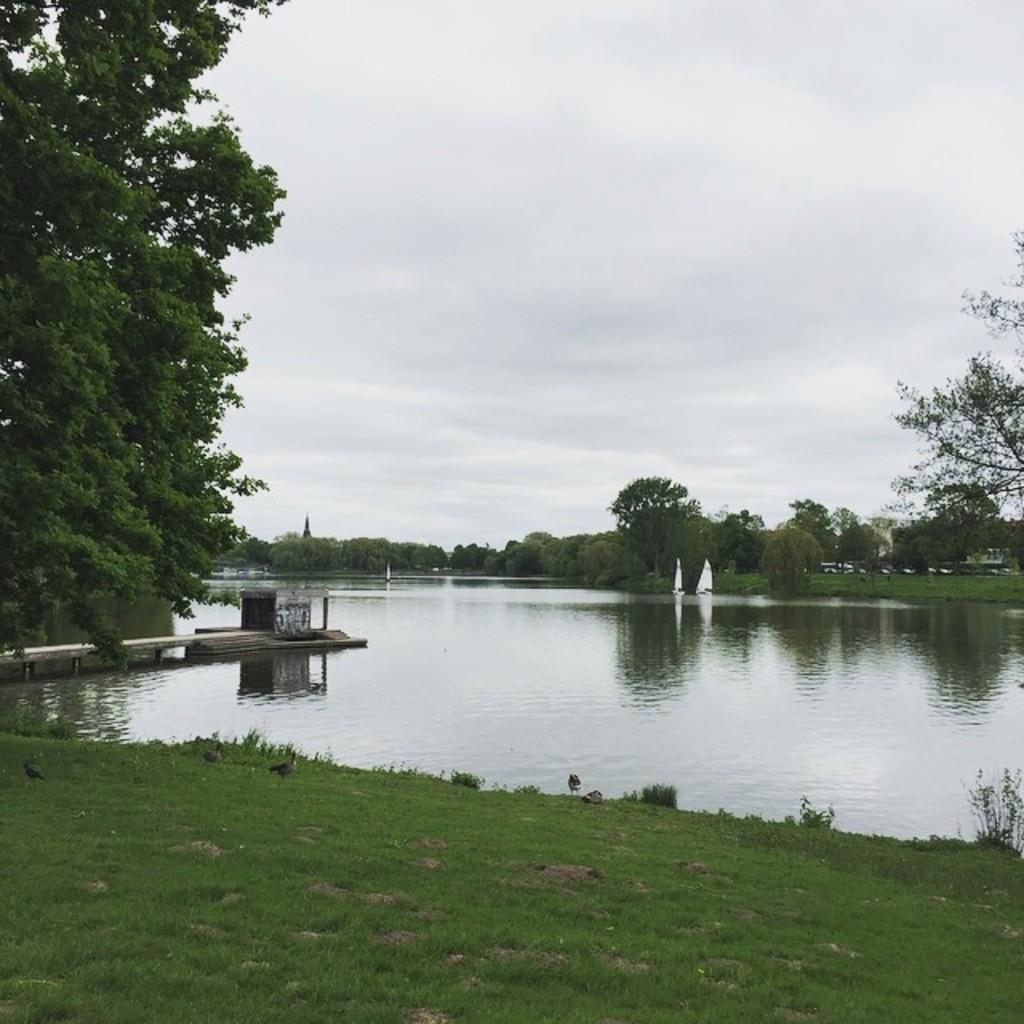How would you summarize this image in a sentence or two? At the bottom we can see grass on the ground and water and on the left side we can see a tree and a platform. In the background we can see boats on the water, trees, vehicles, buildings and clouds in the sky. 